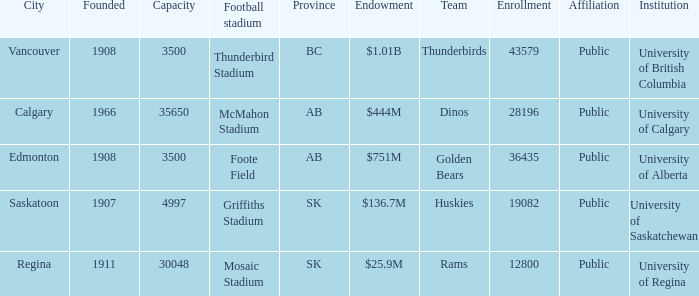What is the year founded for the team Dinos? 1966.0. 